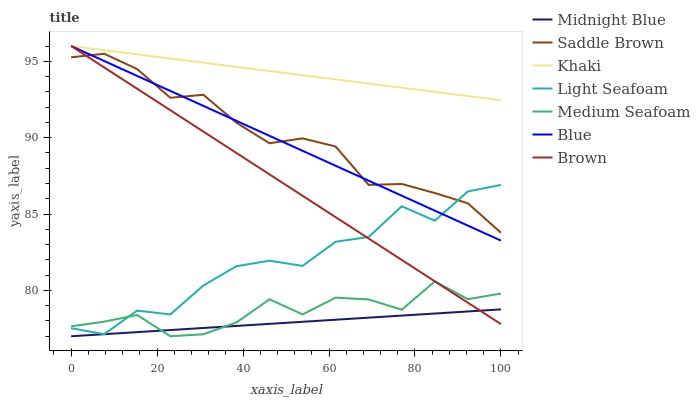Does Midnight Blue have the minimum area under the curve?
Answer yes or no. Yes. Does Khaki have the maximum area under the curve?
Answer yes or no. Yes. Does Brown have the minimum area under the curve?
Answer yes or no. No. Does Brown have the maximum area under the curve?
Answer yes or no. No. Is Midnight Blue the smoothest?
Answer yes or no. Yes. Is Light Seafoam the roughest?
Answer yes or no. Yes. Is Brown the smoothest?
Answer yes or no. No. Is Brown the roughest?
Answer yes or no. No. Does Brown have the lowest value?
Answer yes or no. No. Does Khaki have the highest value?
Answer yes or no. Yes. Does Midnight Blue have the highest value?
Answer yes or no. No. Is Medium Seafoam less than Blue?
Answer yes or no. Yes. Is Saddle Brown greater than Medium Seafoam?
Answer yes or no. Yes. Does Brown intersect Saddle Brown?
Answer yes or no. Yes. Is Brown less than Saddle Brown?
Answer yes or no. No. Is Brown greater than Saddle Brown?
Answer yes or no. No. Does Medium Seafoam intersect Blue?
Answer yes or no. No. 